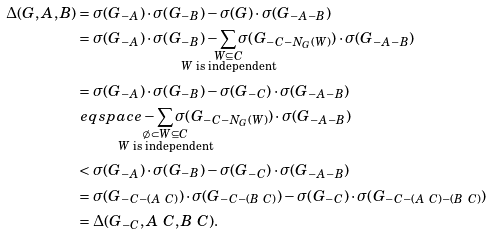<formula> <loc_0><loc_0><loc_500><loc_500>\Delta ( G , A , B ) & = \sigma ( G _ { - A } ) \cdot \sigma ( G _ { - B } ) - \sigma ( G ) \cdot \sigma ( G _ { - A - B } ) \\ & = \sigma ( G _ { - A } ) \cdot \sigma ( G _ { - B } ) - \sum _ { \mathclap { \substack { W \subseteq C \\ W \text { is independent} } } } { \sigma ( G _ { - C - N _ { G } ( W ) } ) } \cdot \sigma ( G _ { - A - B } ) \\ & = \sigma ( G _ { - A } ) \cdot \sigma ( G _ { - B } ) - \sigma ( G _ { - C } ) \cdot \sigma ( G _ { - A - B } ) \\ & \ e q s p a c e - \sum _ { \mathclap { \substack { \emptyset \subset W \subseteq C \\ W \text { is independent} } } } { \sigma ( G _ { - C - N _ { G } ( W ) } ) } \cdot \sigma ( G _ { - A - B } ) \\ & < \sigma ( G _ { - A } ) \cdot \sigma ( G _ { - B } ) - \sigma ( G _ { - C } ) \cdot \sigma ( G _ { - A - B } ) \\ & = \sigma ( G _ { - C - ( A \ C ) } ) \cdot \sigma ( G _ { - C - ( B \ C ) } ) - \sigma ( G _ { - C } ) \cdot \sigma ( G _ { - C - ( A \ C ) - ( B \ C ) } ) \\ & = \Delta ( G _ { - C } , A \ C , B \ C ) .</formula> 